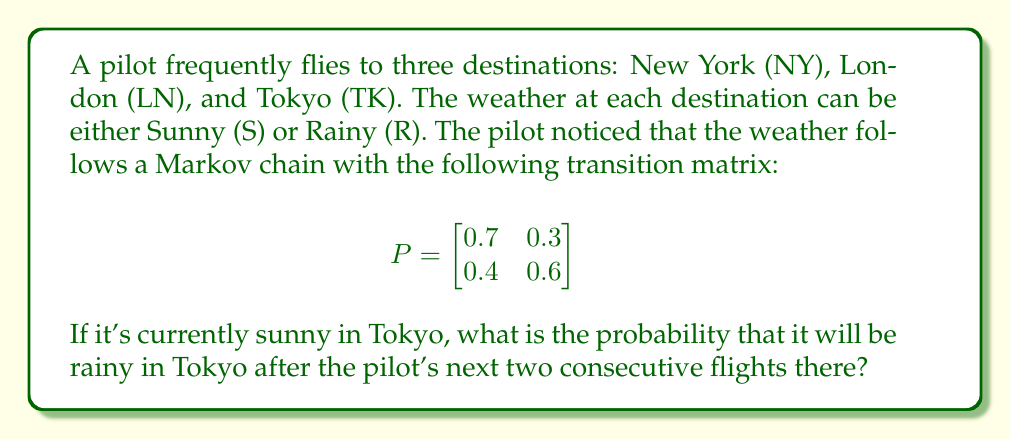Give your solution to this math problem. Let's approach this step-by-step:

1) First, we need to understand what the question is asking. We're looking for the probability of rainy weather after two time steps, given that it's currently sunny.

2) In the transition matrix:
   - $P(S|S) = 0.7$ (probability of sunny given it was sunny)
   - $P(R|S) = 0.3$ (probability of rainy given it was sunny)
   - $P(S|R) = 0.4$ (probability of sunny given it was rainy)
   - $P(R|R) = 0.6$ (probability of rainy given it was rainy)

3) To find the probability after two steps, we need to calculate $P^2$:

   $$
   P^2 = \begin{bmatrix}
   0.7 & 0.3 \\
   0.4 & 0.6
   \end{bmatrix} \times \begin{bmatrix}
   0.7 & 0.3 \\
   0.4 & 0.6
   \end{bmatrix}
   $$

4) Multiplying these matrices:

   $$
   P^2 = \begin{bmatrix}
   (0.7 \times 0.7 + 0.3 \times 0.4) & (0.7 \times 0.3 + 0.3 \times 0.6) \\
   (0.4 \times 0.7 + 0.6 \times 0.4) & (0.4 \times 0.3 + 0.6 \times 0.6)
   \end{bmatrix}
   $$

5) Simplifying:

   $$
   P^2 = \begin{bmatrix}
   0.61 & 0.39 \\
   0.52 & 0.48
   \end{bmatrix}
   $$

6) Since it's currently sunny, we're interested in the probability of transitioning from sunny to rainy after two steps. This is given by the element in the first row, second column of $P^2$, which is 0.39.

Therefore, the probability that it will be rainy in Tokyo after the pilot's next two consecutive flights there, given that it's currently sunny, is 0.39 or 39%.
Answer: 0.39 